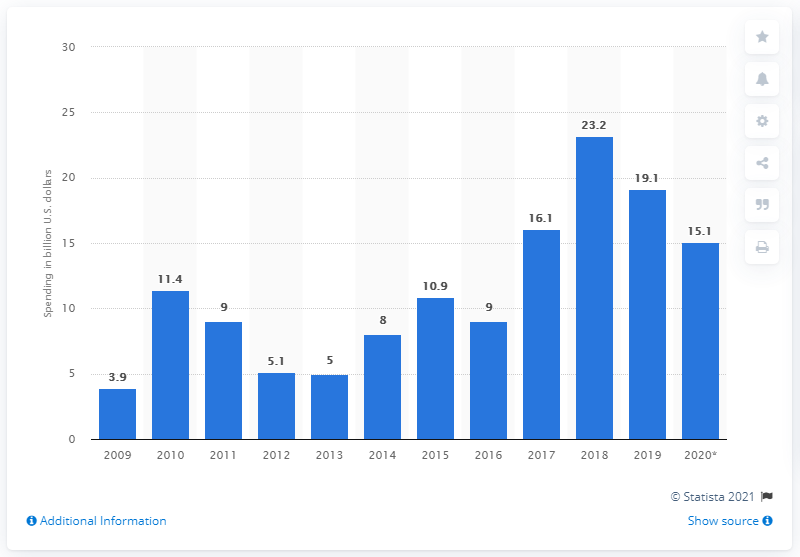Specify some key components in this picture. According to forecasts, capital spending on DRAM by the global memory industry is expected to decrease to 15.1 billion U.S. dollars in 2020, down from an estimated 20.4 billion U.S. dollars in 2019. 